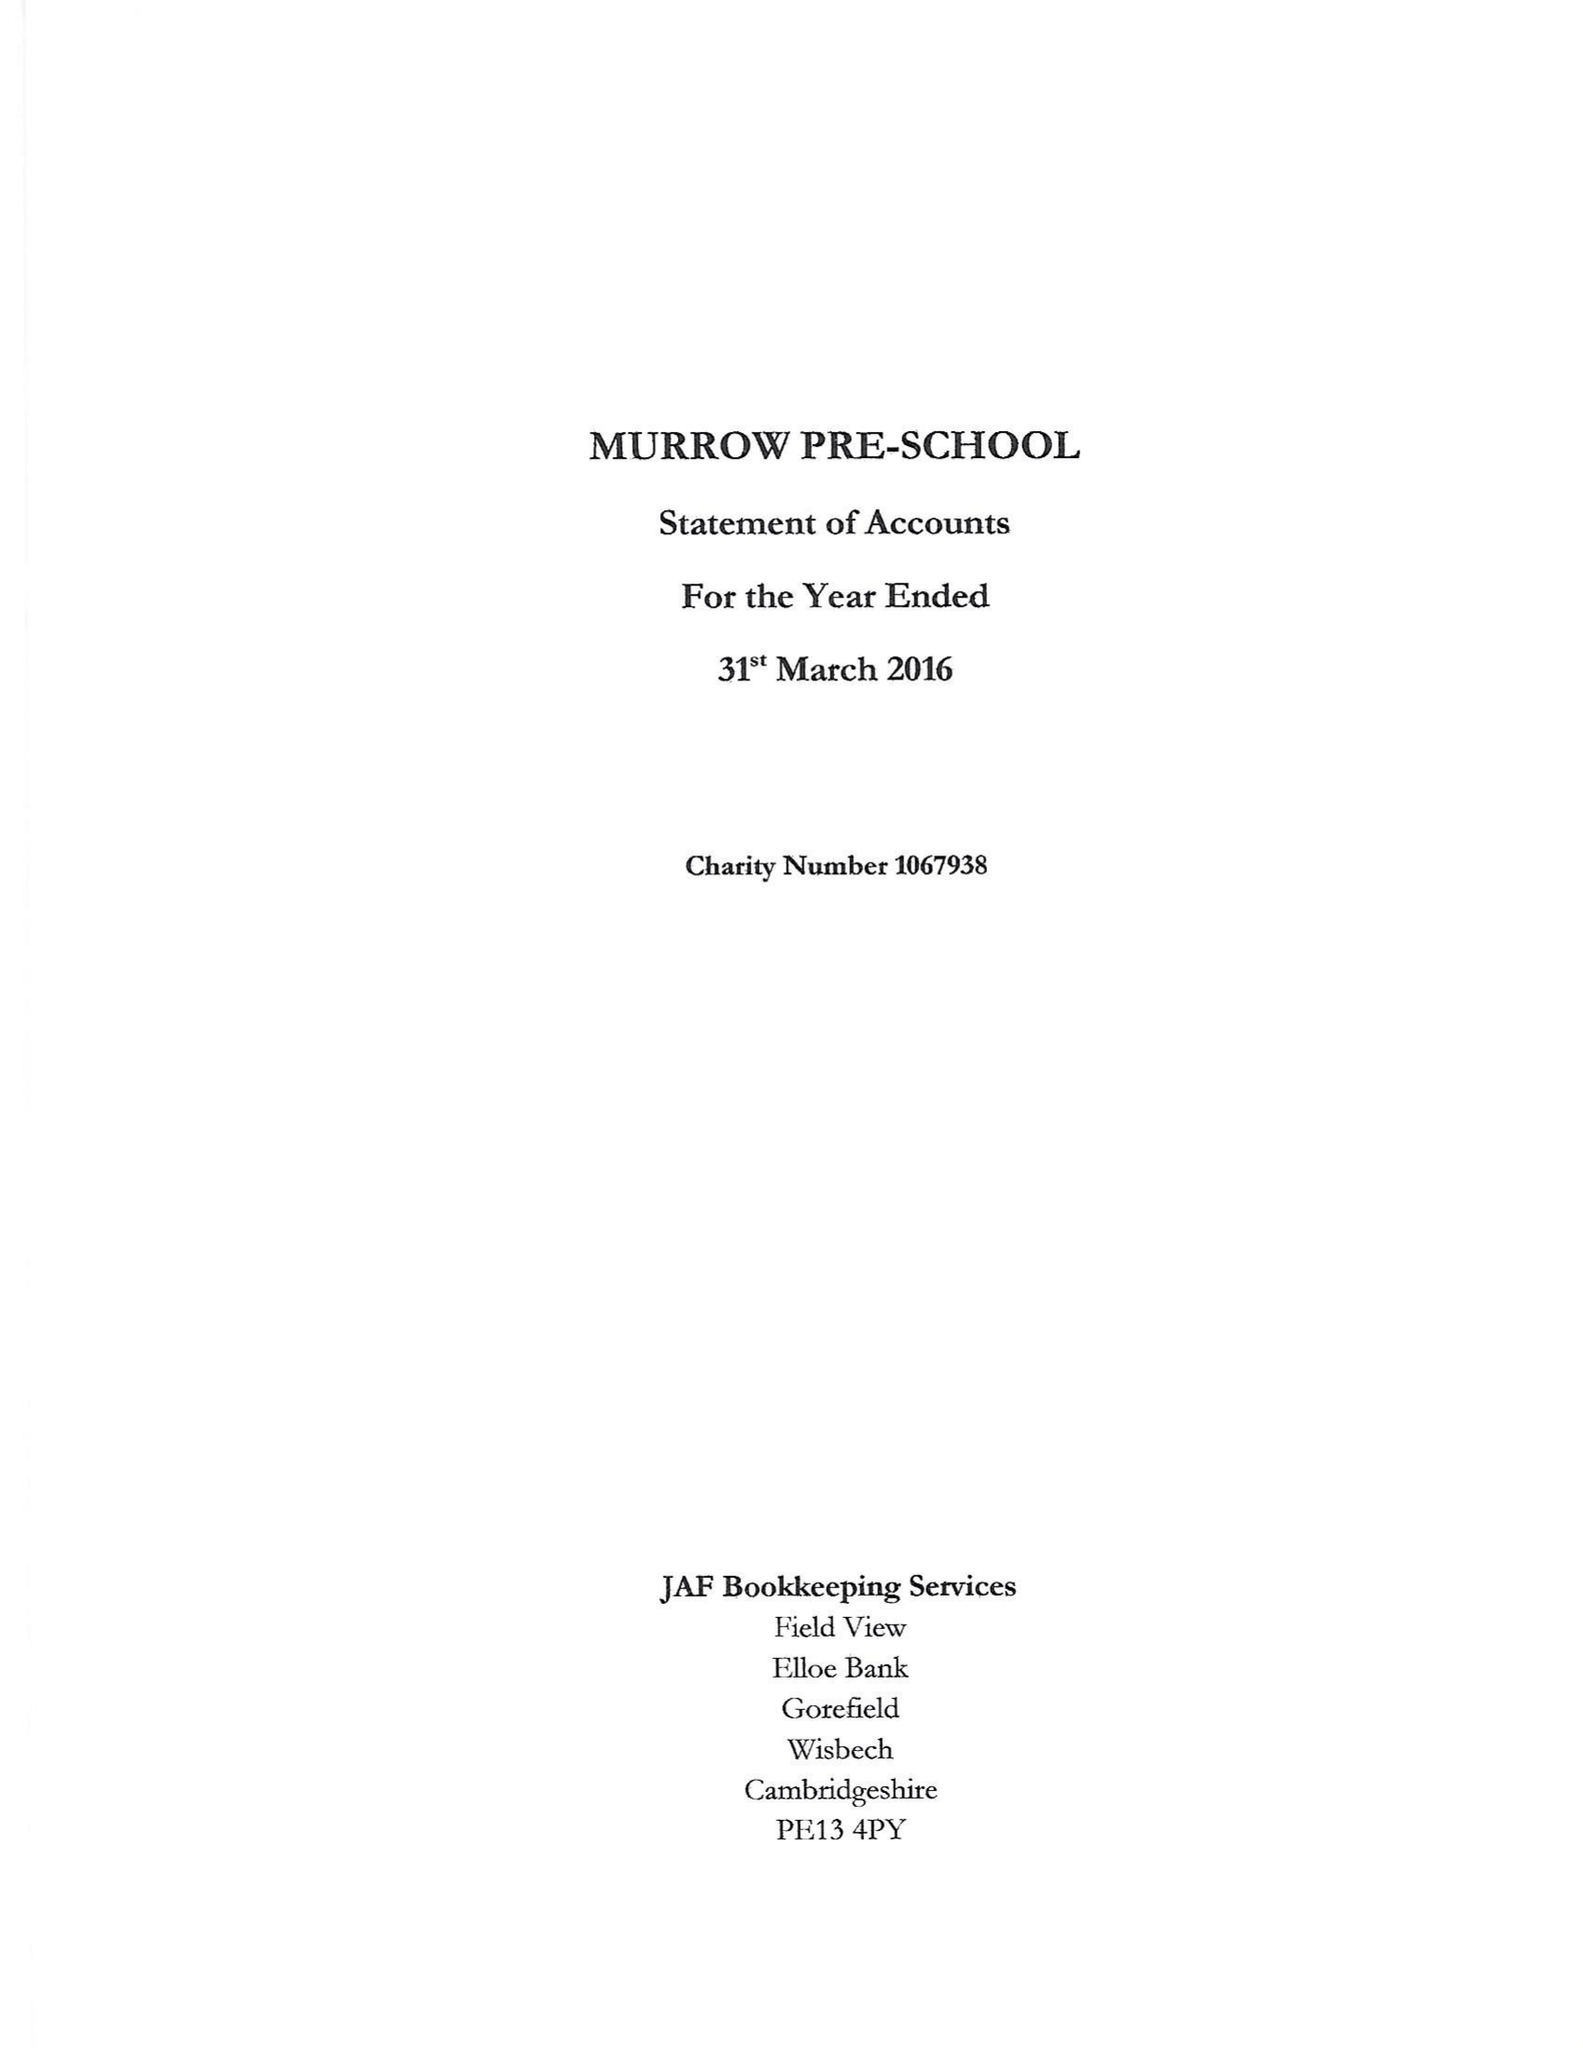What is the value for the report_date?
Answer the question using a single word or phrase. 2016-03-31 